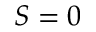<formula> <loc_0><loc_0><loc_500><loc_500>S = 0</formula> 